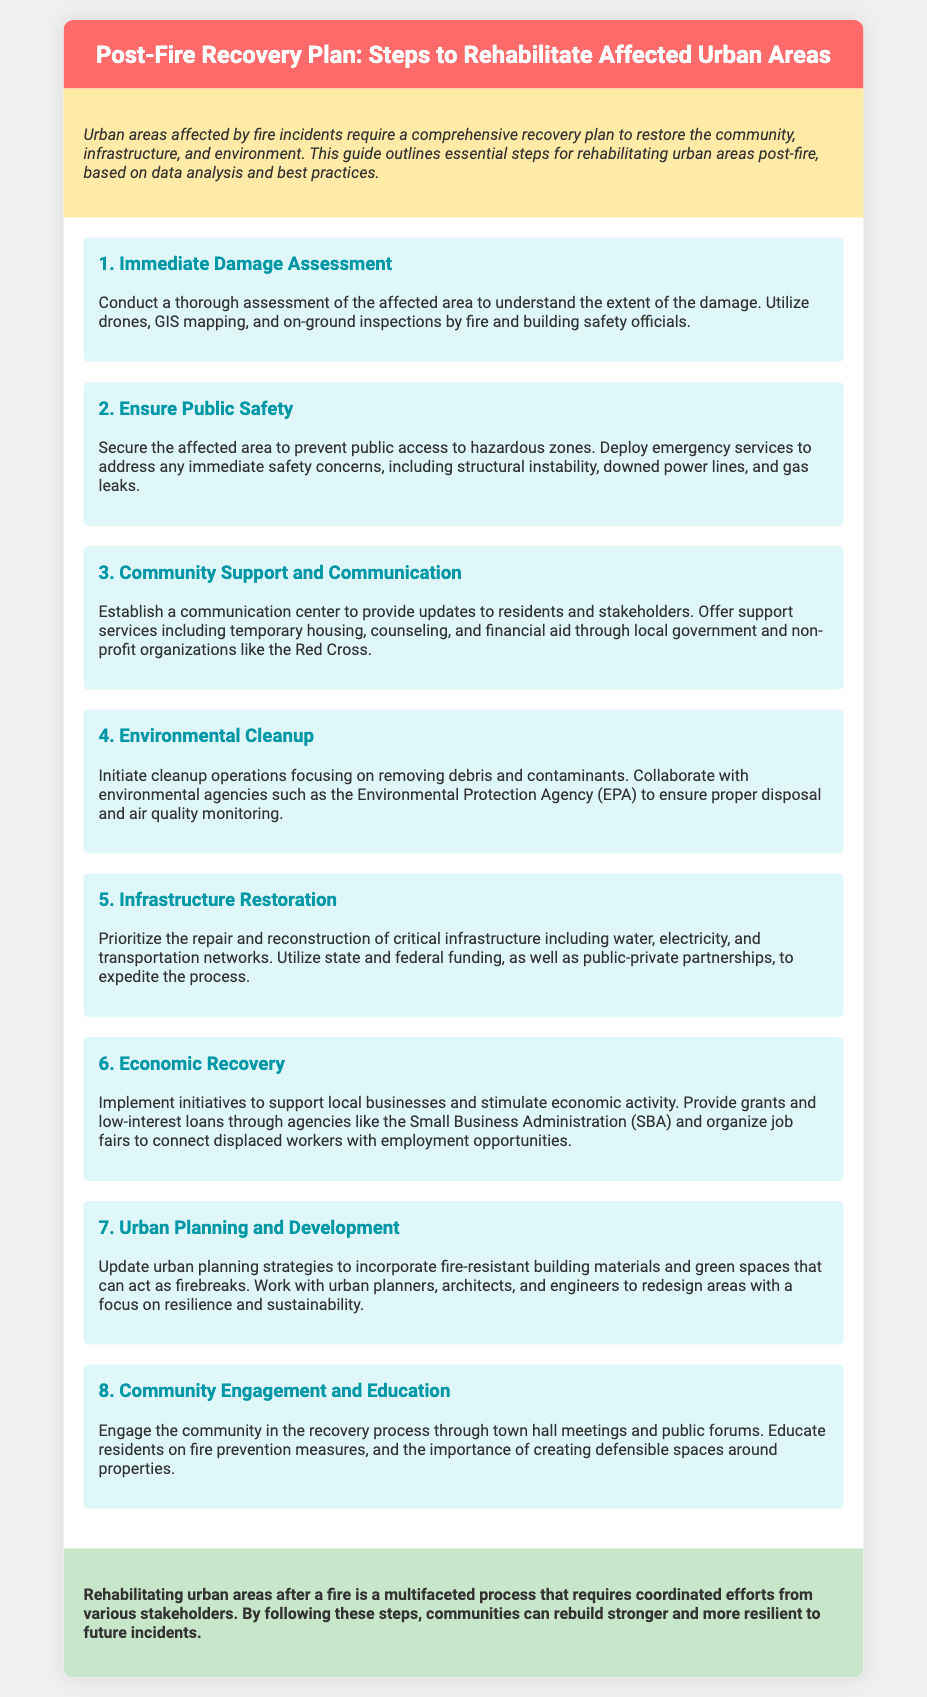What is the first step in the recovery plan? The first step in the recovery plan is to conduct a thorough assessment of the affected area.
Answer: Immediate Damage Assessment What initiative is suggested for local businesses? The document suggests providing grants and low-interest loans to support local businesses.
Answer: Grants and low-interest loans What agency is mentioned for environmental cleanup collaboration? The Environmental Protection Agency is mentioned for collaboration in cleanup operations.
Answer: EPA How many steps are outlined in the recovery plan? The number of steps outlined in the recovery plan is provided in the document.
Answer: Eight What should be updated in urban planning strategies? The urban planning strategies should incorporate fire-resistant building materials and green spaces.
Answer: Fire-resistant building materials and green spaces What is the purpose of the communication center? The purpose of the communication center is to provide updates to residents and stakeholders.
Answer: Provide updates What type of meetings should be held for community engagement? Town hall meetings should be held for community engagement during the recovery process.
Answer: Town hall meetings What color represents the header in the document? The header's background color in the document is described in its style section.
Answer: Red 